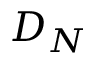<formula> <loc_0><loc_0><loc_500><loc_500>D _ { N }</formula> 